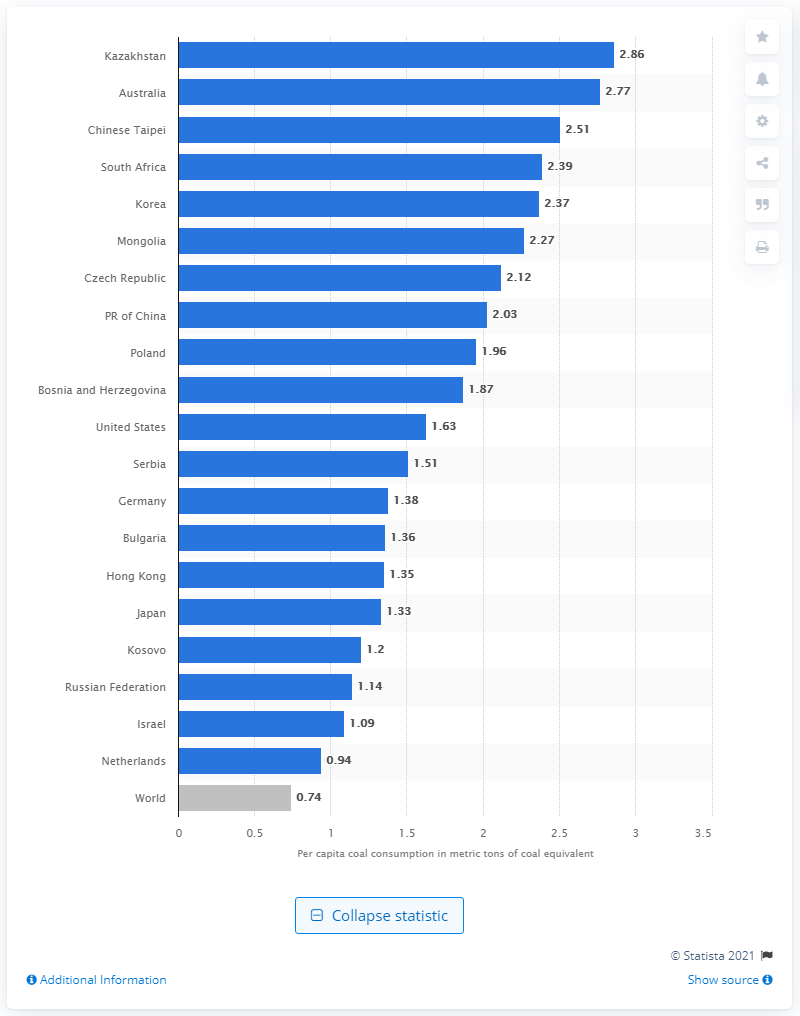Indicate a few pertinent items in this graphic. Australia is one of the world's largest per capita consumers. 